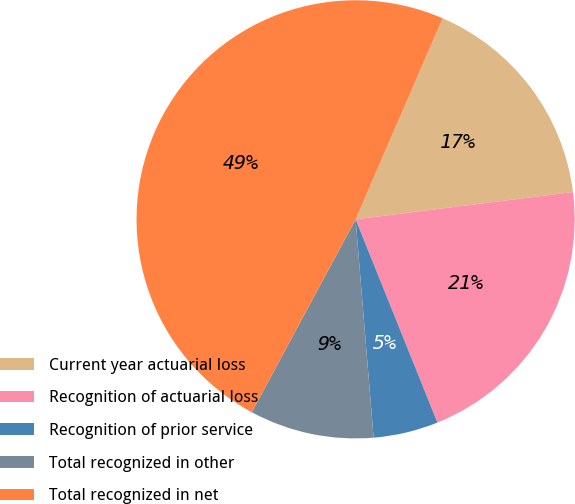Convert chart to OTSL. <chart><loc_0><loc_0><loc_500><loc_500><pie_chart><fcel>Current year actuarial loss<fcel>Recognition of actuarial loss<fcel>Recognition of prior service<fcel>Total recognized in other<fcel>Total recognized in net<nl><fcel>16.51%<fcel>20.9%<fcel>4.78%<fcel>9.17%<fcel>48.64%<nl></chart> 